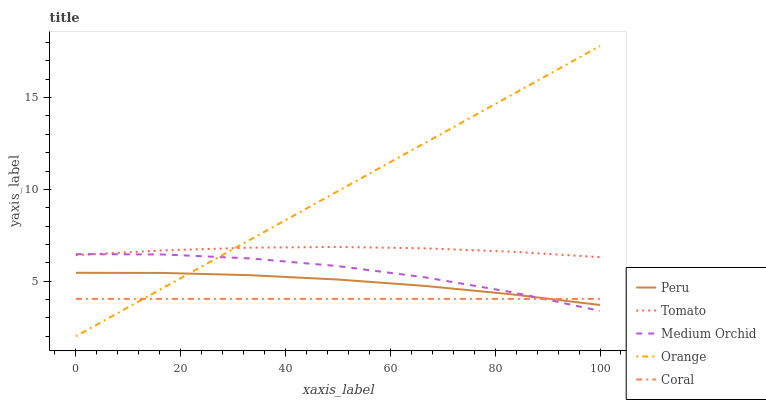Does Coral have the minimum area under the curve?
Answer yes or no. Yes. Does Orange have the maximum area under the curve?
Answer yes or no. Yes. Does Orange have the minimum area under the curve?
Answer yes or no. No. Does Coral have the maximum area under the curve?
Answer yes or no. No. Is Orange the smoothest?
Answer yes or no. Yes. Is Medium Orchid the roughest?
Answer yes or no. Yes. Is Coral the smoothest?
Answer yes or no. No. Is Coral the roughest?
Answer yes or no. No. Does Orange have the lowest value?
Answer yes or no. Yes. Does Coral have the lowest value?
Answer yes or no. No. Does Orange have the highest value?
Answer yes or no. Yes. Does Coral have the highest value?
Answer yes or no. No. Is Peru less than Tomato?
Answer yes or no. Yes. Is Tomato greater than Peru?
Answer yes or no. Yes. Does Medium Orchid intersect Tomato?
Answer yes or no. Yes. Is Medium Orchid less than Tomato?
Answer yes or no. No. Is Medium Orchid greater than Tomato?
Answer yes or no. No. Does Peru intersect Tomato?
Answer yes or no. No. 